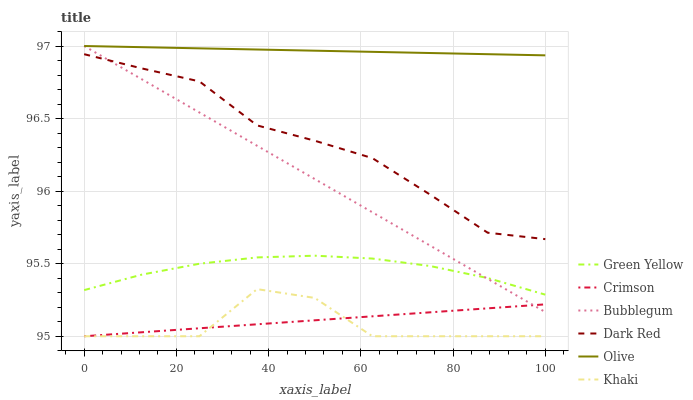Does Khaki have the minimum area under the curve?
Answer yes or no. Yes. Does Olive have the maximum area under the curve?
Answer yes or no. Yes. Does Dark Red have the minimum area under the curve?
Answer yes or no. No. Does Dark Red have the maximum area under the curve?
Answer yes or no. No. Is Olive the smoothest?
Answer yes or no. Yes. Is Khaki the roughest?
Answer yes or no. Yes. Is Dark Red the smoothest?
Answer yes or no. No. Is Dark Red the roughest?
Answer yes or no. No. Does Khaki have the lowest value?
Answer yes or no. Yes. Does Dark Red have the lowest value?
Answer yes or no. No. Does Olive have the highest value?
Answer yes or no. Yes. Does Dark Red have the highest value?
Answer yes or no. No. Is Khaki less than Olive?
Answer yes or no. Yes. Is Olive greater than Crimson?
Answer yes or no. Yes. Does Crimson intersect Bubblegum?
Answer yes or no. Yes. Is Crimson less than Bubblegum?
Answer yes or no. No. Is Crimson greater than Bubblegum?
Answer yes or no. No. Does Khaki intersect Olive?
Answer yes or no. No. 